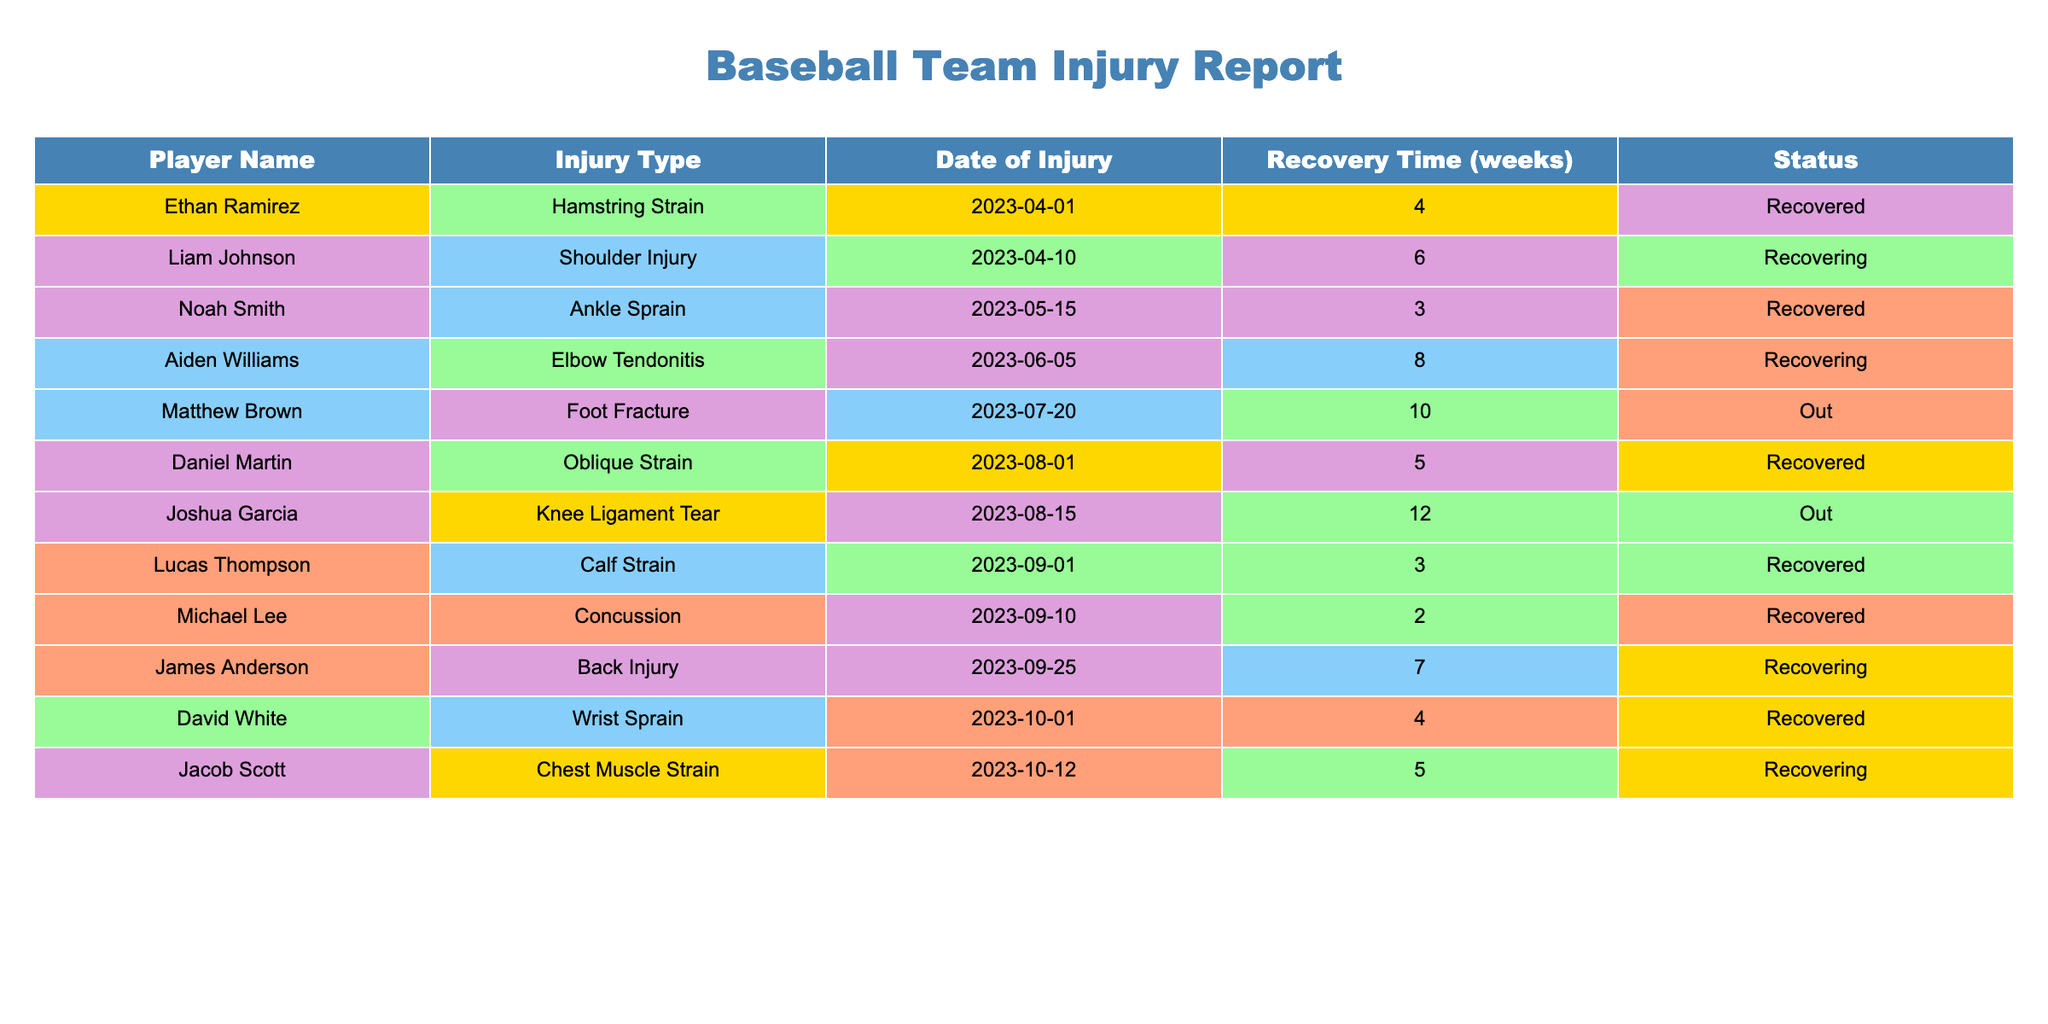What is the name of the player who has a knee ligament tear? By scanning the 'Player Name' column in the table, I look for the injury type "Knee Ligament Tear." The player associated with that injury is Joshua Garcia.
Answer: Joshua Garcia How many players are currently out due to injuries? In the 'Status' column, I check for the number of players marked as "Out." There are two players listed as "Out" — Matthew Brown and Joshua Garcia.
Answer: 2 What is the recovery time for Aiden Williams? I find Aiden Williams in the 'Player Name' column and check the corresponding 'Recovery Time' value listed, which is 8 weeks.
Answer: 8 weeks Which player has the shortest recovery time and what is it? I look through the 'Recovery Time' column for the smallest value. The shortest recovery time is 2 weeks for Michael Lee.
Answer: 2 weeks Is Liam Johnson fully recovered? I refer to the 'Status' column and find that Liam Johnson is marked as "Recovering," which indicates he has not fully recovered yet.
Answer: No What is the average recovery time of all players who have fully recovered? I identify the players with 'Status' as "Recovered" and their corresponding recovery times: 4 (Ethan Ramirez) + 3 (Noah Smith) + 3 (Lucas Thompson) + 2 (Michael Lee) + 4 (David White) = 16 weeks. There are 5 players, so average = 16/5 = 3.2 weeks.
Answer: 3.2 weeks How long will it take before James Anderson is fully recovered? I look at the 'Status' column and see James Anderson is "Recovering" and has a recovery time of 7 weeks. Since he is currently recovering, I take 7 weeks as his remaining recovery time.
Answer: 7 weeks If Daniel Martin recovers, how many weeks will he have missed playing? Daniel Martin's recovery time is 5 weeks, and the current date is 2023-10-01. Since his injury was on 2023-08-01 and he is now all recovered, he will miss 5 weeks of the season due to recovery.
Answer: 5 weeks Which injury has the longest recovery time, and who is affected by it? I look for the maximum value in the 'Recovery Time' column, which is 12 weeks for Joshua Garcia with a "Knee Ligament Tear."
Answer: Knee Ligament Tear, Joshua Garcia How many players have shoulder or elbow injuries combined? I check the 'Injury Type' column for counts of players with "Shoulder Injury" (1 player: Liam Johnson) and "Elbow Tendonitis" (1 player: Aiden Williams), totaling 2 players combined.
Answer: 2 players Has Noah Smith ever had an injury? I can see from the 'Player Name' column that Noah Smith has an entry, which specifies he had an "Ankle Sprain." Thus, he has experienced an injury.
Answer: Yes 